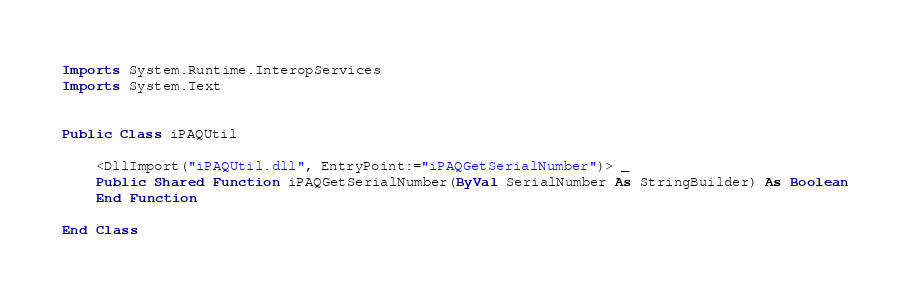Convert code to text. <code><loc_0><loc_0><loc_500><loc_500><_VisualBasic_>Imports System.Runtime.InteropServices
Imports System.Text


Public Class iPAQUtil

    <DllImport("iPAQUtil.dll", EntryPoint:="iPAQGetSerialNumber")> _
    Public Shared Function iPAQGetSerialNumber(ByVal SerialNumber As StringBuilder) As Boolean
    End Function

End Class
</code> 